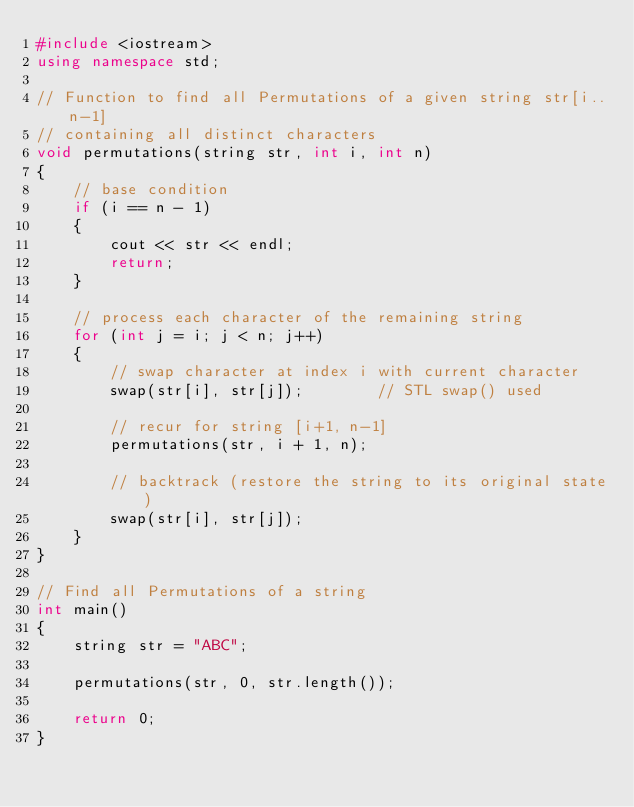<code> <loc_0><loc_0><loc_500><loc_500><_C++_>#include <iostream>
using namespace std;

// Function to find all Permutations of a given string str[i..n-1]
// containing all distinct characters
void permutations(string str, int i, int n)
{
    // base condition
    if (i == n - 1)
    {
        cout << str << endl;
        return;
    }

    // process each character of the remaining string
    for (int j = i; j < n; j++)
    {
        // swap character at index i with current character
        swap(str[i], str[j]);        // STL swap() used

        // recur for string [i+1, n-1]
        permutations(str, i + 1, n);

        // backtrack (restore the string to its original state)
        swap(str[i], str[j]);
    }
}

// Find all Permutations of a string
int main()
{
    string str = "ABC";

    permutations(str, 0, str.length());

    return 0;
}
</code> 